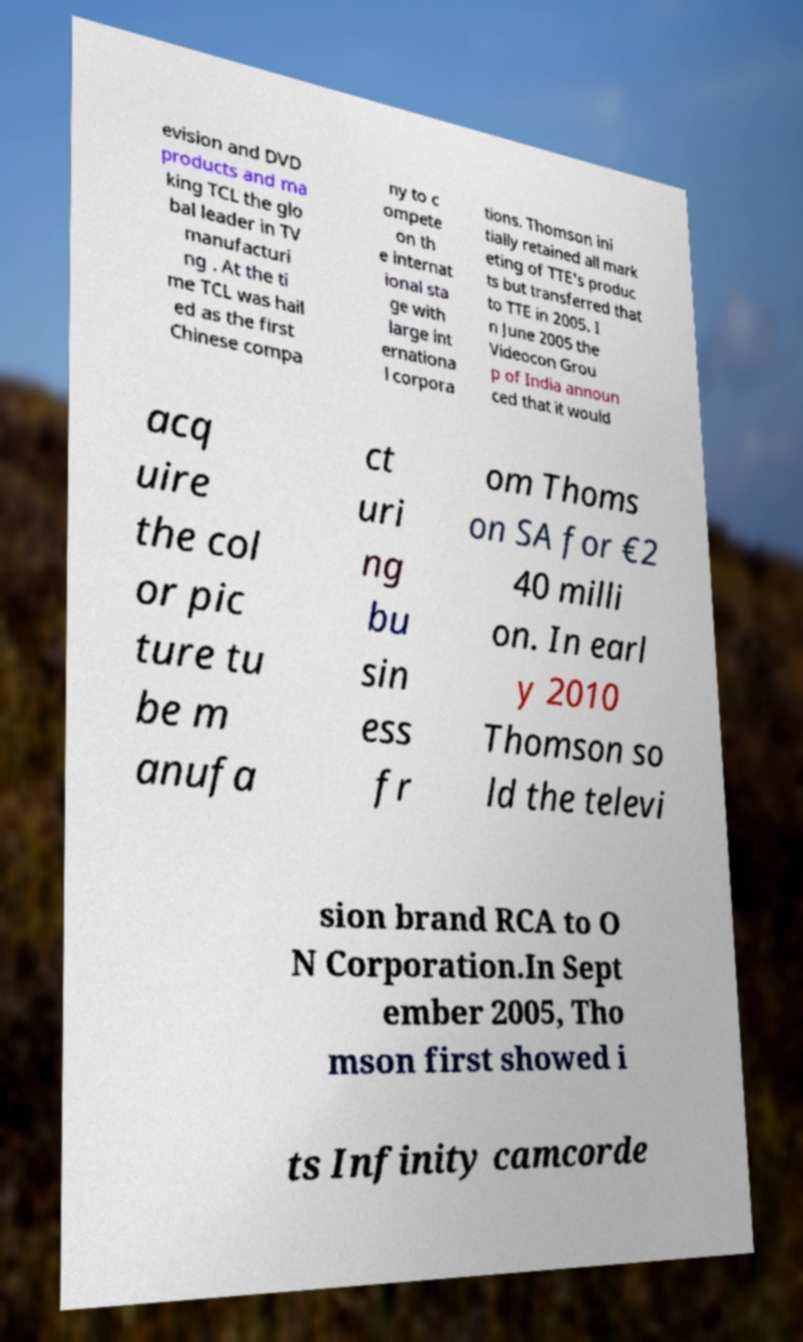Please identify and transcribe the text found in this image. evision and DVD products and ma king TCL the glo bal leader in TV manufacturi ng . At the ti me TCL was hail ed as the first Chinese compa ny to c ompete on th e internat ional sta ge with large int ernationa l corpora tions. Thomson ini tially retained all mark eting of TTE's produc ts but transferred that to TTE in 2005. I n June 2005 the Videocon Grou p of India announ ced that it would acq uire the col or pic ture tu be m anufa ct uri ng bu sin ess fr om Thoms on SA for €2 40 milli on. In earl y 2010 Thomson so ld the televi sion brand RCA to O N Corporation.In Sept ember 2005, Tho mson first showed i ts Infinity camcorde 